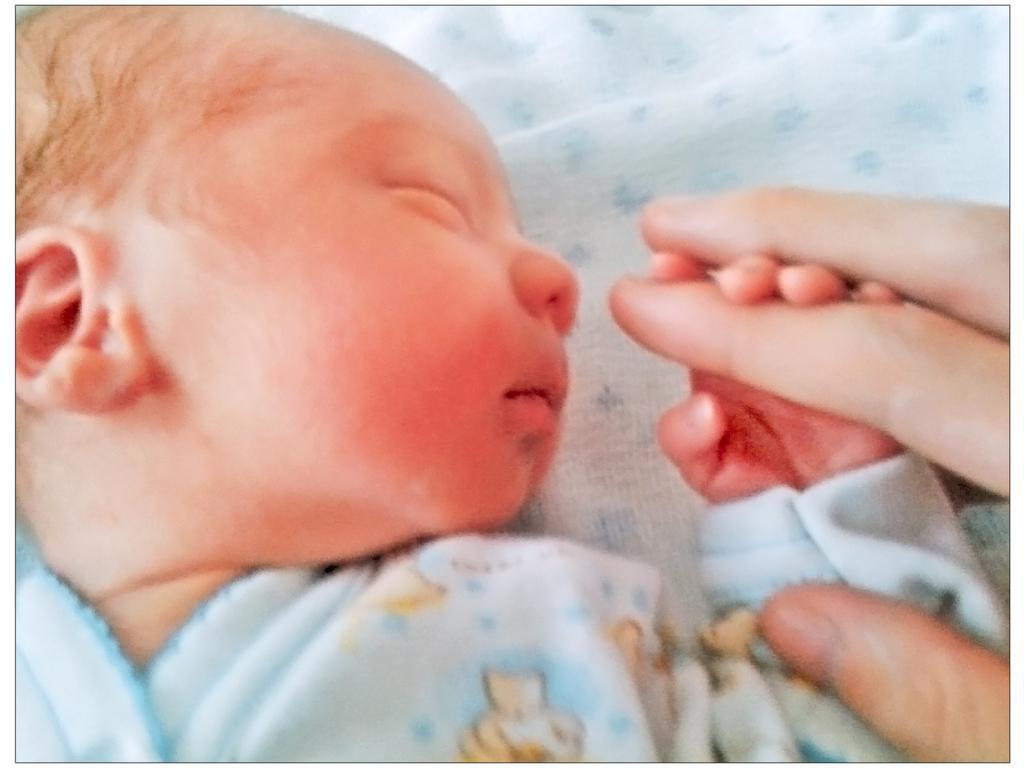In one or two sentences, can you explain what this image depicts? In this picture we can see a baby holding a finger of a person. 